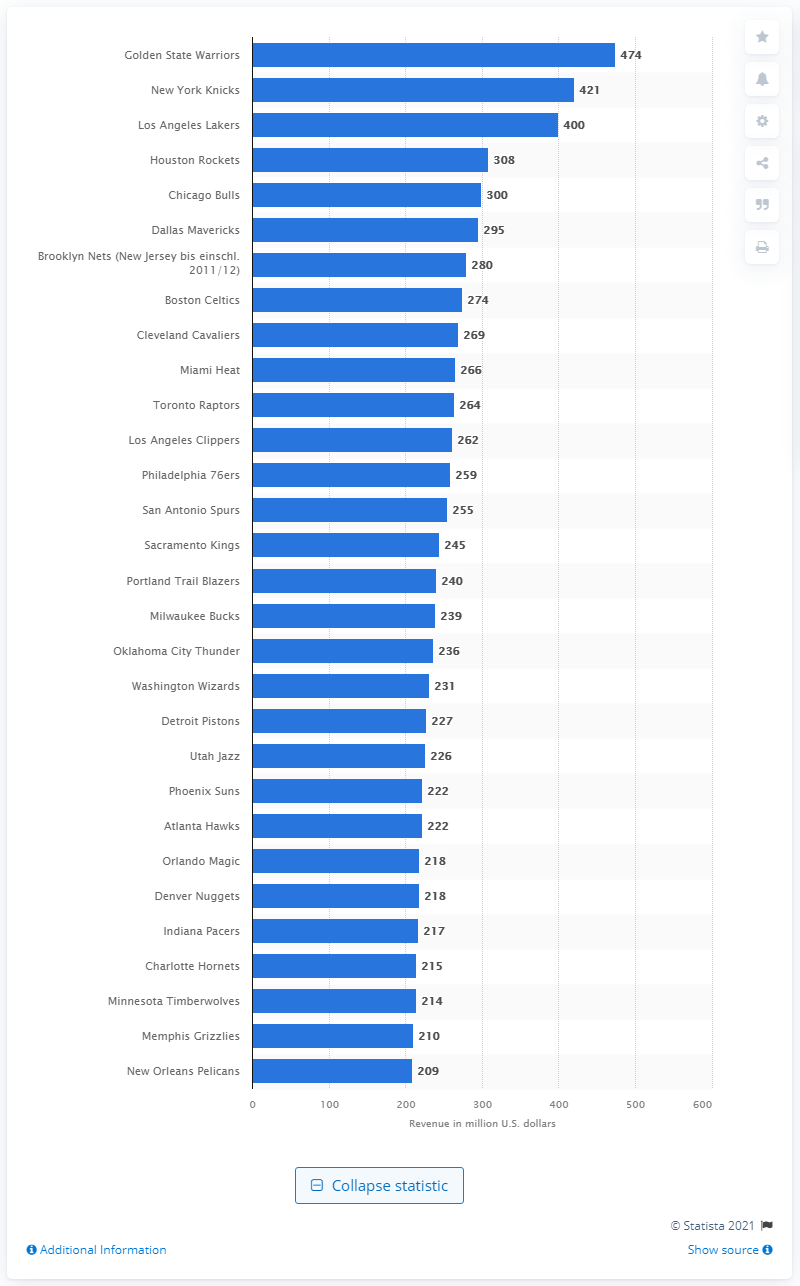Indicate a few pertinent items in this graphic. The Los Angeles Lakers generated approximately $474 million in revenue during the 2019/2020 season. 